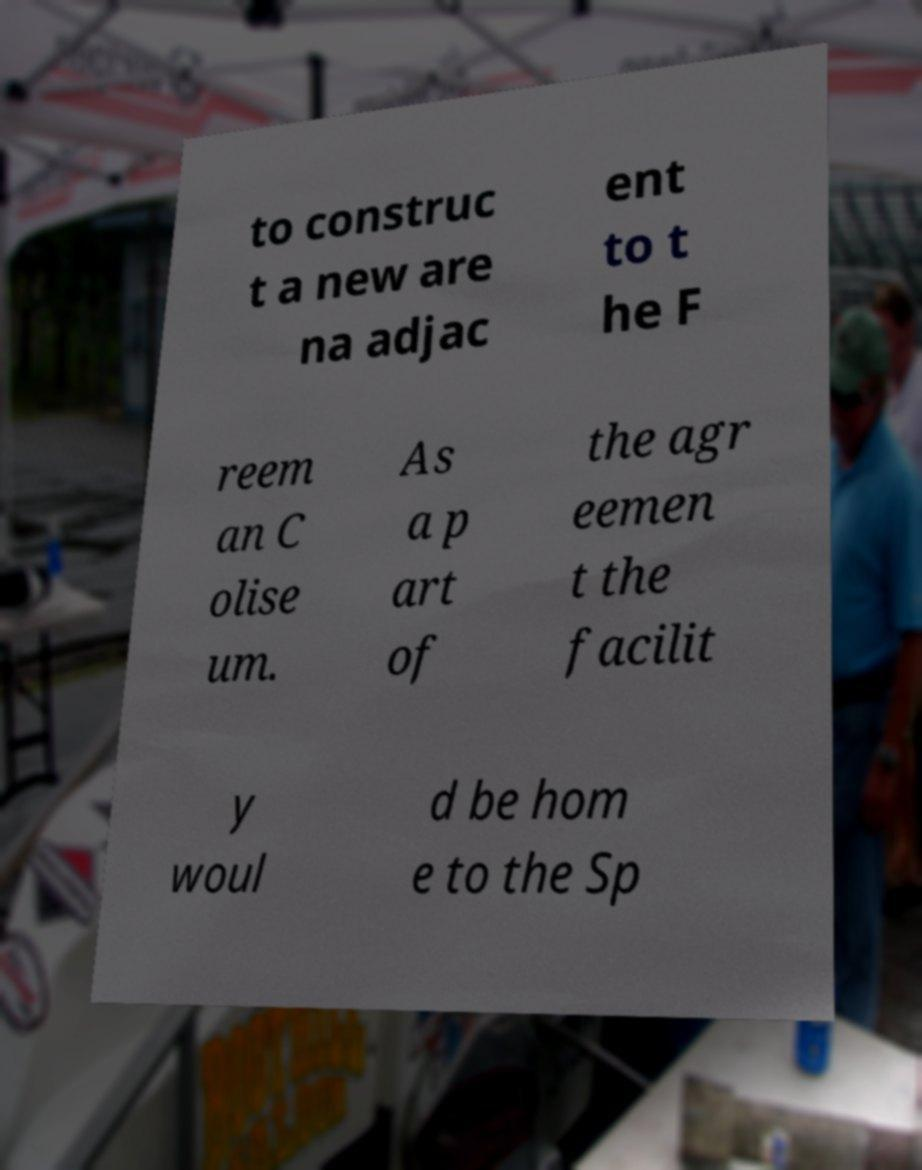Can you read and provide the text displayed in the image?This photo seems to have some interesting text. Can you extract and type it out for me? to construc t a new are na adjac ent to t he F reem an C olise um. As a p art of the agr eemen t the facilit y woul d be hom e to the Sp 